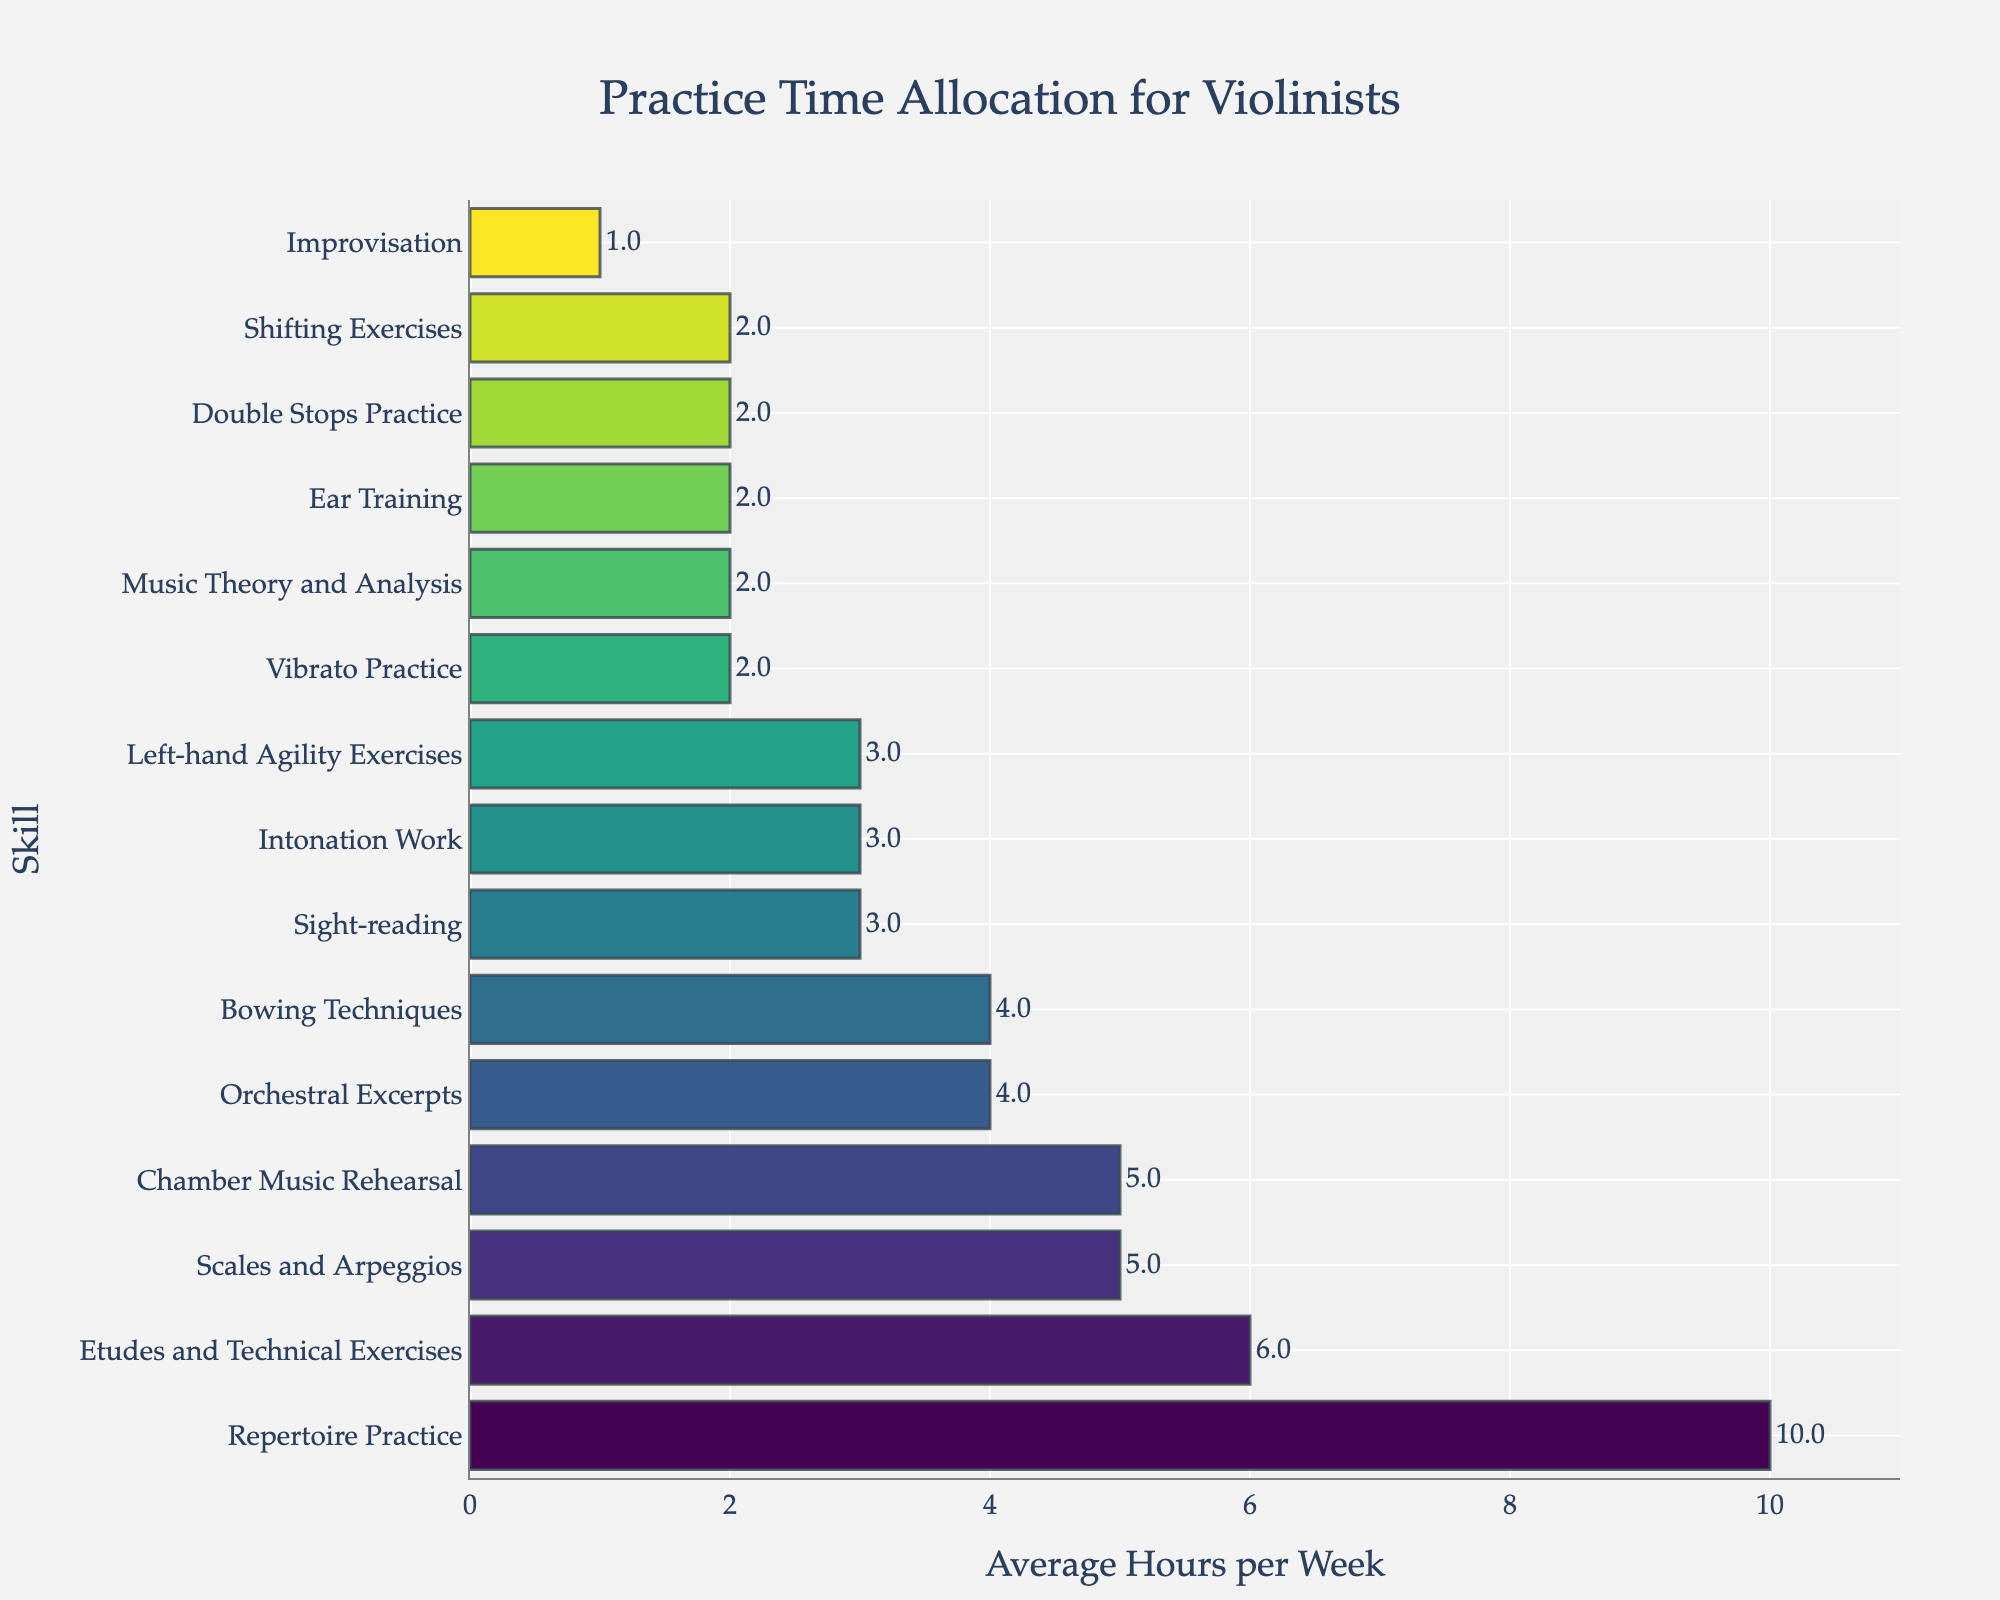What skill has the highest average hours per week? To find out which skill has the highest average hours per week, look for the longest bar in the bar chart. The longest bar corresponds to Repertoire Practice.
Answer: Repertoire Practice What is the average number of hours spent on Scales and Arpeggios and Bowing Techniques combined? To calculate this, add the average hours for Scales and Arpeggios (5 hours) and Bowing Techniques (4 hours). So, 5 + 4 = 9 hours.
Answer: 9 Which skills have an average of 3 hours per week? To answer this, identify the bars that reach up to the 3-hour mark. These skills are Sight-reading, Intonation Work, and Left-hand Agility Exercises.
Answer: Sight-reading, Intonation Work, Left-hand Agility Exercises How many more hours are spent on Repertoire Practice compared to Improvisation? Subtract the number of hours spent on Improvisation (1 hour) from the number of hours spent on Repertoire Practice (10 hours). So, 10 - 1 = 9 hours.
Answer: 9 What is the total average practice time for Ear Training, Vibrato Practice, and Shifting Exercises? Add the average hours for Ear Training (2 hours), Vibrato Practice (2 hours), and Shifting Exercises (2 hours). So, 2 + 2 + 2 = 6 hours.
Answer: 6 Which skill is practiced equally as much as Music Theory and Analysis? Identify the skill that has the same length of the bar as Music Theory and Analysis, which is 2 hours. That skill is Ear Training and Vibrato Practice.
Answer: Ear Training, Vibrato Practice How much time is spent on Chamber Music Rehearsal compared to Orchestral Excerpts? Identify the bars for Chamber Music Rehearsal (5 hours) and Orchestral Excerpts (4 hours). Subtract the two values: 5 - 4 = 1 hour.
Answer: 1 What is the combined practice time for the three least practiced skills? Add the average hours for the three least practiced skills, which are Improvisation (1 hour), Music Theory and Analysis (2 hours), and Ear Training (2 hours). So, 1 + 2 + 2 = 5 hours.
Answer: 5 What skills are practiced for exactly 2 hours per week? Identify the bars that reach the 2-hour mark. These skills are Vibrato Practice, Music Theory and Analysis, Ear Training, Double Stops Practice, and Shifting Exercises.
Answer: Vibrato Practice, Music Theory and Analysis, Ear Training, Double Stops Practice, Shifting Exercises 